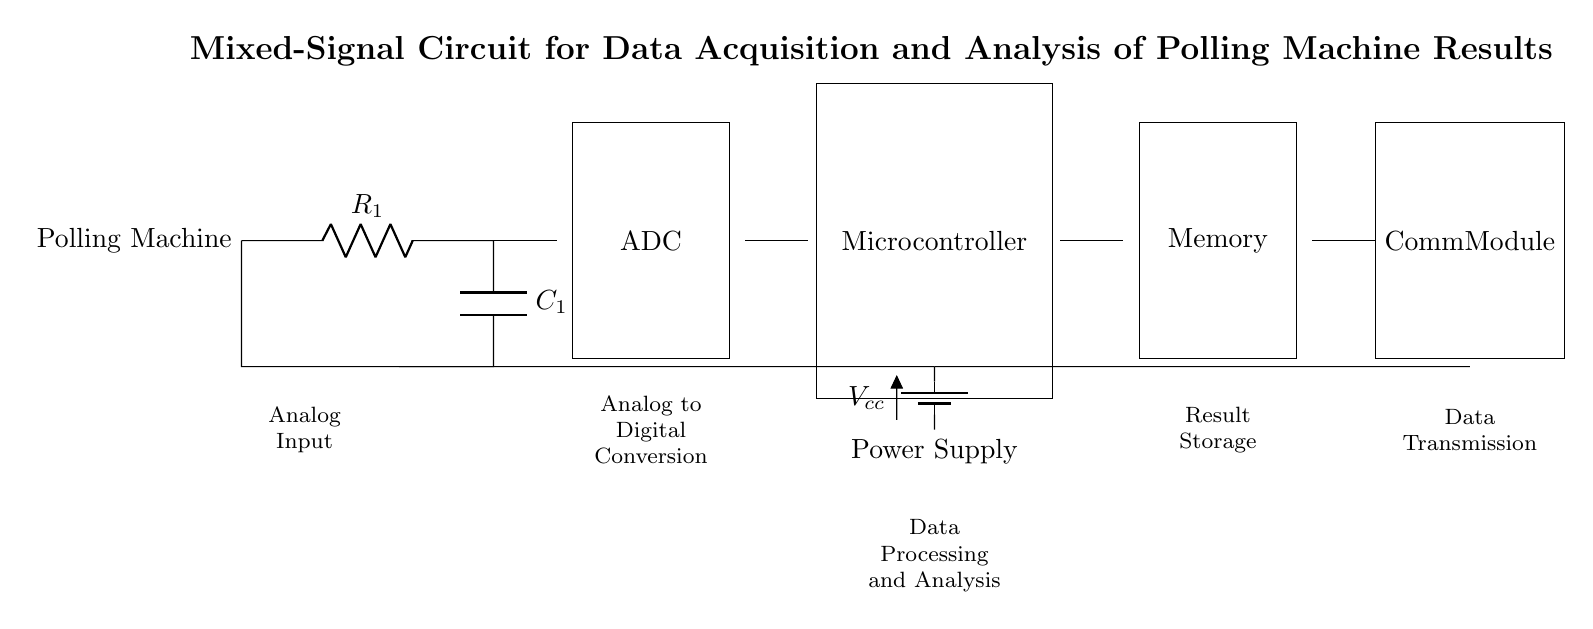What is the component type used for Analog Input? The diagram shows a resistor labeled R1 connected to the polling machine for the analog input. Resistors are commonly used for signal conditioning by limiting current or dividing voltage.
Answer: Resistor What is the function of the ADC in this circuit? The ADC, or Analog to Digital Converter, converts the analog signals from the polling machine into digital signals that can be processed by the microcontroller. This conversion is essential for digital analysis and storage.
Answer: Conversion How many components are involved in the digital processing phase? The digital processing phase in this circuit includes the microcontroller, which is responsible for executing the data analysis based on the input it receives from the ADC. Analyzing the diagram shows only one component for data processing here.
Answer: One What voltage does the circuit use for the power supply? The circuit is powered by a battery labeled Vcc. Typically, Vcc is a reference to the positive voltage supply in electronic circuits, commonly around 5V for microcontroller applications.
Answer: Vcc What is the primary purpose of the Memory component in this circuit? The Memory in this circuit is used to store the digital data processed by the microcontroller. It temporarily holds the results of the polling machine data acquisition for later retrieval and analysis.
Answer: Storage How does the data transmission occur in this circuit? Data transmission is carried out by the Communication Module, which takes the processed data from the Memory and sends it to external devices or systems. This module facilitates the communication of digital results obtained from the polling machine.
Answer: Communication Module 